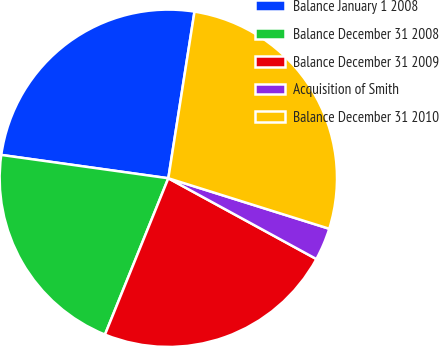Convert chart. <chart><loc_0><loc_0><loc_500><loc_500><pie_chart><fcel>Balance January 1 2008<fcel>Balance December 31 2008<fcel>Balance December 31 2009<fcel>Acquisition of Smith<fcel>Balance December 31 2010<nl><fcel>25.27%<fcel>21.08%<fcel>23.18%<fcel>3.11%<fcel>27.36%<nl></chart> 